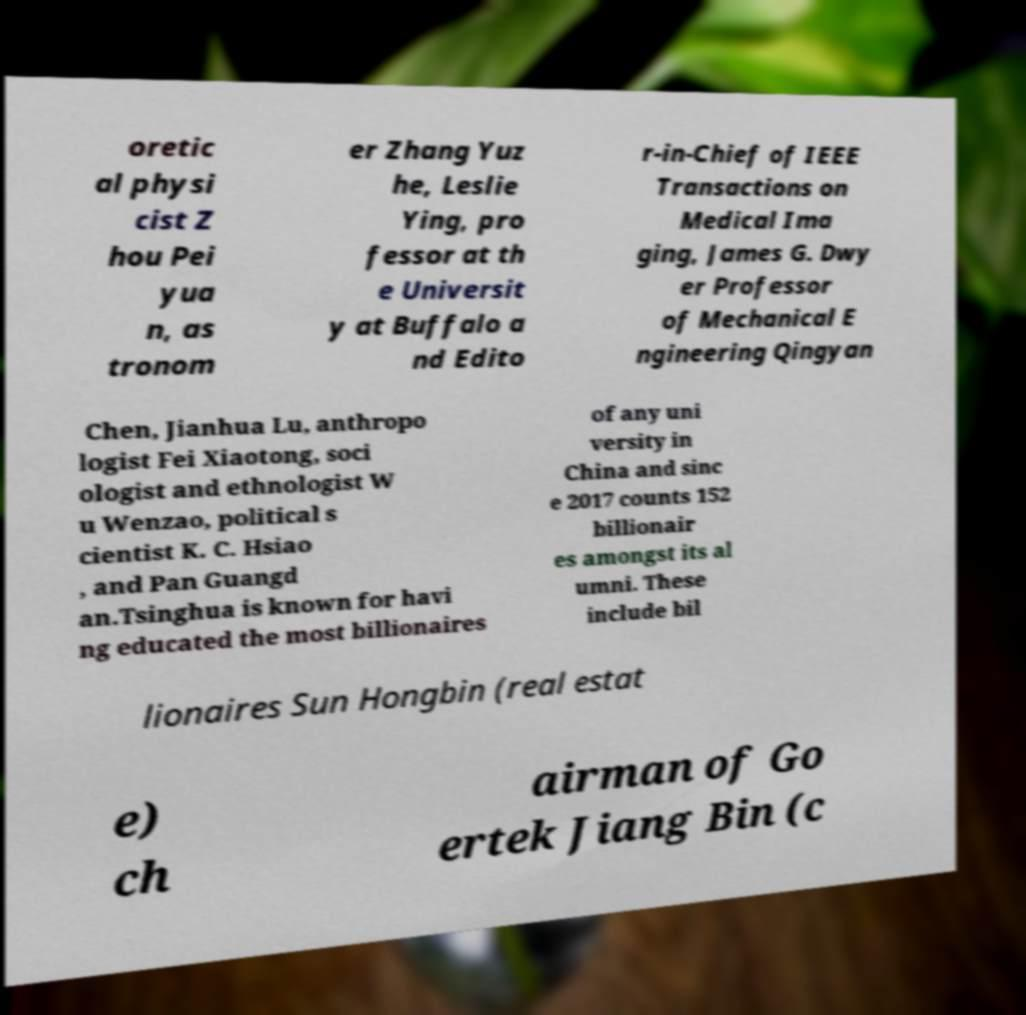Can you accurately transcribe the text from the provided image for me? oretic al physi cist Z hou Pei yua n, as tronom er Zhang Yuz he, Leslie Ying, pro fessor at th e Universit y at Buffalo a nd Edito r-in-Chief of IEEE Transactions on Medical Ima ging, James G. Dwy er Professor of Mechanical E ngineering Qingyan Chen, Jianhua Lu, anthropo logist Fei Xiaotong, soci ologist and ethnologist W u Wenzao, political s cientist K. C. Hsiao , and Pan Guangd an.Tsinghua is known for havi ng educated the most billionaires of any uni versity in China and sinc e 2017 counts 152 billionair es amongst its al umni. These include bil lionaires Sun Hongbin (real estat e) ch airman of Go ertek Jiang Bin (c 